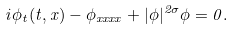<formula> <loc_0><loc_0><loc_500><loc_500>i \phi _ { t } ( t , x ) - \phi _ { x x x x } + | \phi | ^ { 2 \sigma } \phi = 0 .</formula> 